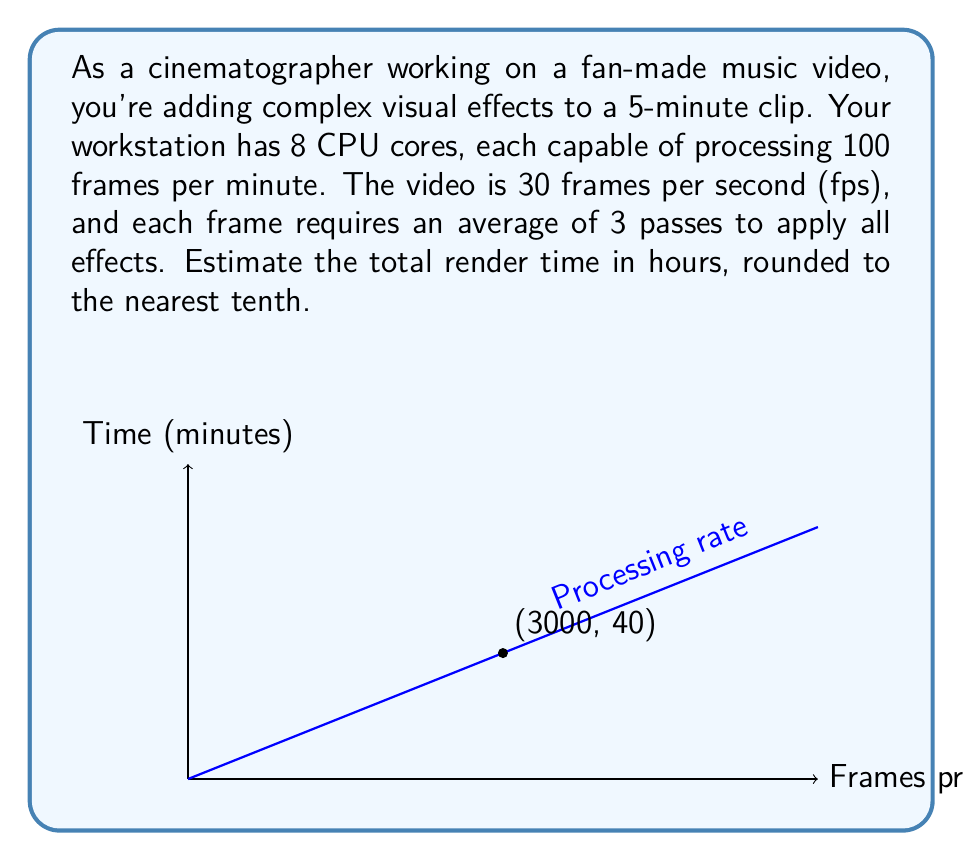Provide a solution to this math problem. Let's break this down step-by-step:

1) First, calculate the total number of frames in the video:
   $$5 \text{ minutes} \times 60 \text{ seconds/minute} \times 30 \text{ fps} = 9000 \text{ frames}$$

2) Each frame needs 3 passes, so the total number of frame processes is:
   $$9000 \text{ frames} \times 3 \text{ passes} = 27000 \text{ frame processes}$$

3) The workstation can process frames at this rate:
   $$8 \text{ cores} \times 100 \text{ frames/minute/core} = 800 \text{ frames/minute}$$

4) The time needed to process all frames:
   $$\frac{27000 \text{ frame processes}}{800 \text{ frames/minute}} = 33.75 \text{ minutes}$$

5) Convert minutes to hours:
   $$\frac{33.75 \text{ minutes}}{60 \text{ minutes/hour}} = 0.5625 \text{ hours}$$

6) Rounding to the nearest tenth:
   $$0.5625 \text{ hours} \approx 0.6 \text{ hours}$$
Answer: 0.6 hours 